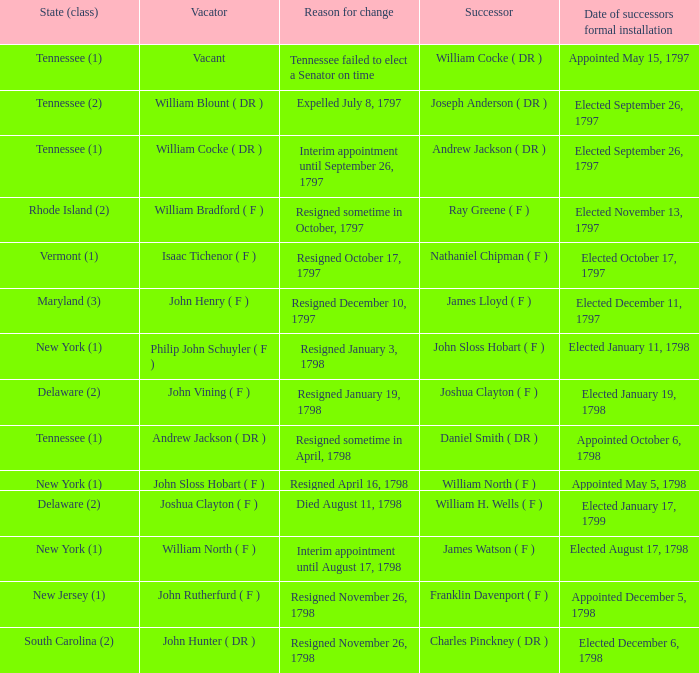What is the total number of successors when the vacator was William North ( F ) 1.0. Would you mind parsing the complete table? {'header': ['State (class)', 'Vacator', 'Reason for change', 'Successor', 'Date of successors formal installation'], 'rows': [['Tennessee (1)', 'Vacant', 'Tennessee failed to elect a Senator on time', 'William Cocke ( DR )', 'Appointed May 15, 1797'], ['Tennessee (2)', 'William Blount ( DR )', 'Expelled July 8, 1797', 'Joseph Anderson ( DR )', 'Elected September 26, 1797'], ['Tennessee (1)', 'William Cocke ( DR )', 'Interim appointment until September 26, 1797', 'Andrew Jackson ( DR )', 'Elected September 26, 1797'], ['Rhode Island (2)', 'William Bradford ( F )', 'Resigned sometime in October, 1797', 'Ray Greene ( F )', 'Elected November 13, 1797'], ['Vermont (1)', 'Isaac Tichenor ( F )', 'Resigned October 17, 1797', 'Nathaniel Chipman ( F )', 'Elected October 17, 1797'], ['Maryland (3)', 'John Henry ( F )', 'Resigned December 10, 1797', 'James Lloyd ( F )', 'Elected December 11, 1797'], ['New York (1)', 'Philip John Schuyler ( F )', 'Resigned January 3, 1798', 'John Sloss Hobart ( F )', 'Elected January 11, 1798'], ['Delaware (2)', 'John Vining ( F )', 'Resigned January 19, 1798', 'Joshua Clayton ( F )', 'Elected January 19, 1798'], ['Tennessee (1)', 'Andrew Jackson ( DR )', 'Resigned sometime in April, 1798', 'Daniel Smith ( DR )', 'Appointed October 6, 1798'], ['New York (1)', 'John Sloss Hobart ( F )', 'Resigned April 16, 1798', 'William North ( F )', 'Appointed May 5, 1798'], ['Delaware (2)', 'Joshua Clayton ( F )', 'Died August 11, 1798', 'William H. Wells ( F )', 'Elected January 17, 1799'], ['New York (1)', 'William North ( F )', 'Interim appointment until August 17, 1798', 'James Watson ( F )', 'Elected August 17, 1798'], ['New Jersey (1)', 'John Rutherfurd ( F )', 'Resigned November 26, 1798', 'Franklin Davenport ( F )', 'Appointed December 5, 1798'], ['South Carolina (2)', 'John Hunter ( DR )', 'Resigned November 26, 1798', 'Charles Pinckney ( DR )', 'Elected December 6, 1798']]} 